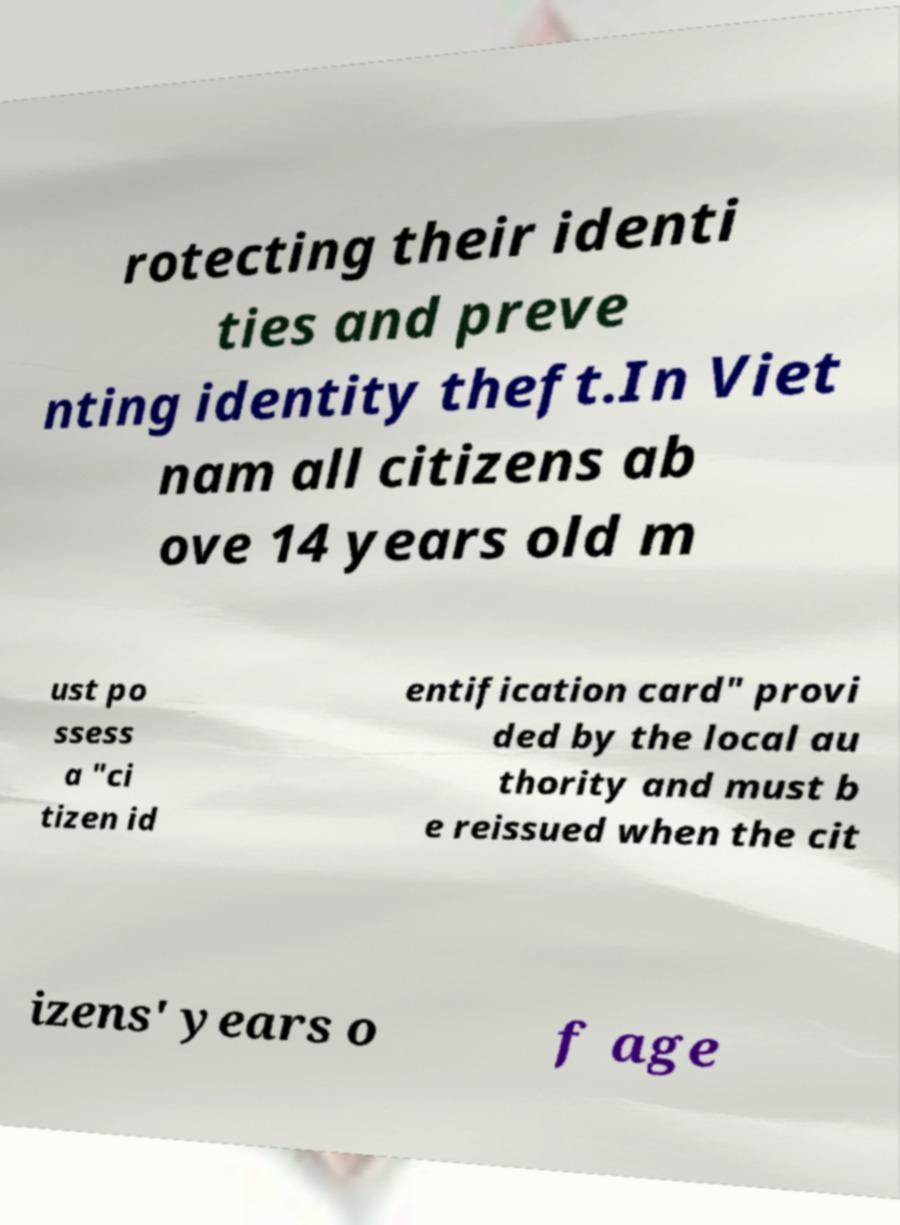For documentation purposes, I need the text within this image transcribed. Could you provide that? rotecting their identi ties and preve nting identity theft.In Viet nam all citizens ab ove 14 years old m ust po ssess a "ci tizen id entification card" provi ded by the local au thority and must b e reissued when the cit izens' years o f age 